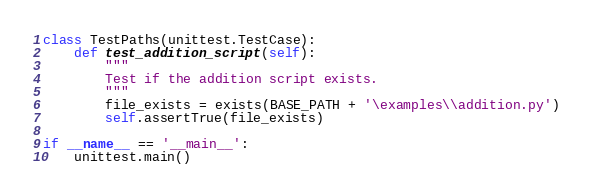<code> <loc_0><loc_0><loc_500><loc_500><_Python_>class TestPaths(unittest.TestCase):
    def test_addition_script(self):
        """
        Test if the addition script exists.
        """
        file_exists = exists(BASE_PATH + '\examples\\addition.py')
        self.assertTrue(file_exists)

if __name__ == '__main__':
    unittest.main()</code> 